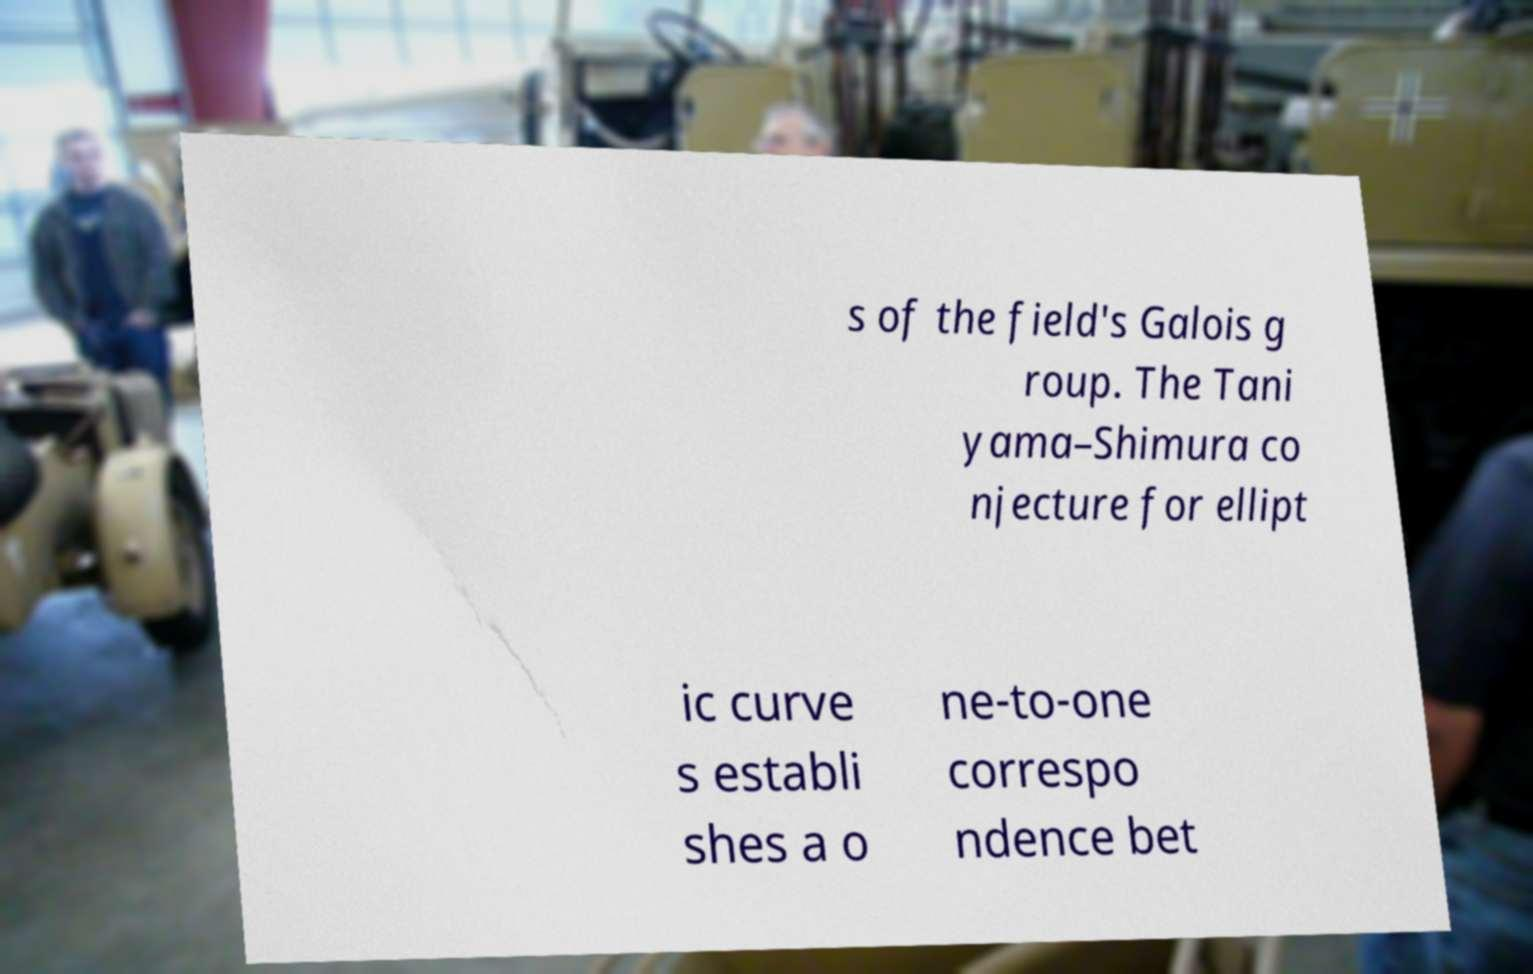Please read and relay the text visible in this image. What does it say? s of the field's Galois g roup. The Tani yama–Shimura co njecture for ellipt ic curve s establi shes a o ne-to-one correspo ndence bet 